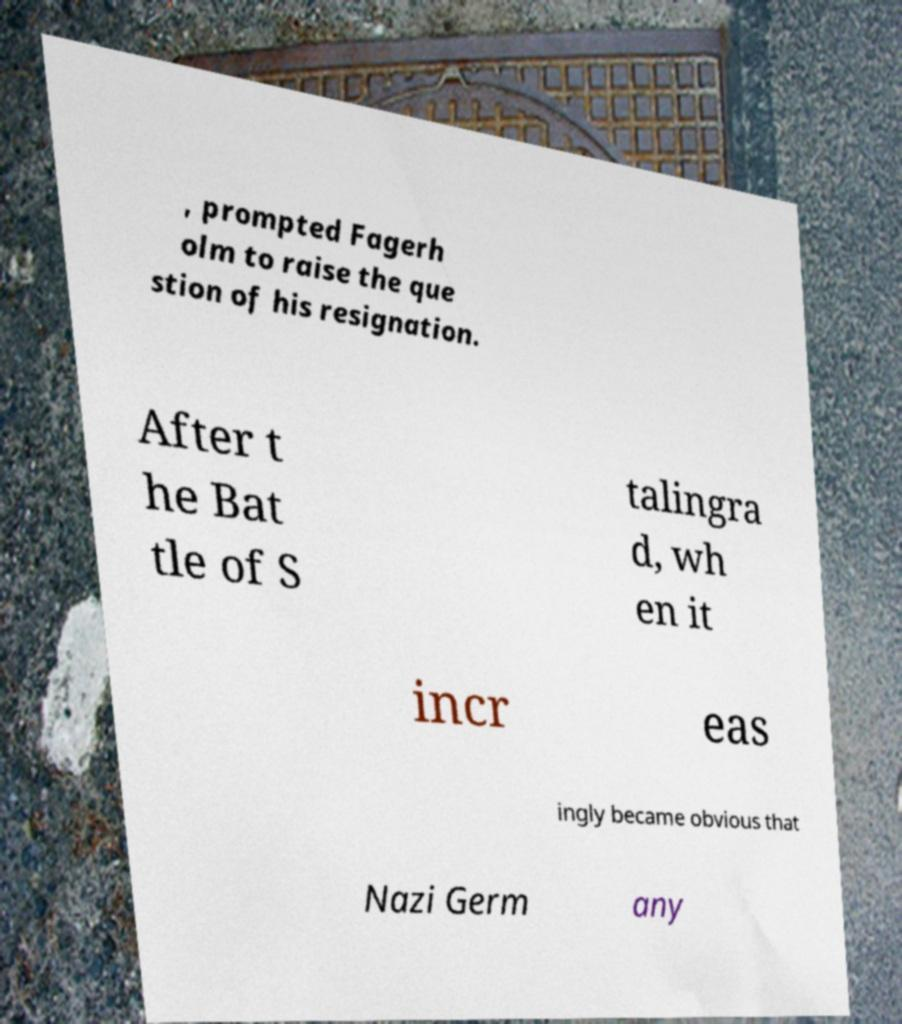Could you assist in decoding the text presented in this image and type it out clearly? , prompted Fagerh olm to raise the que stion of his resignation. After t he Bat tle of S talingra d, wh en it incr eas ingly became obvious that Nazi Germ any 